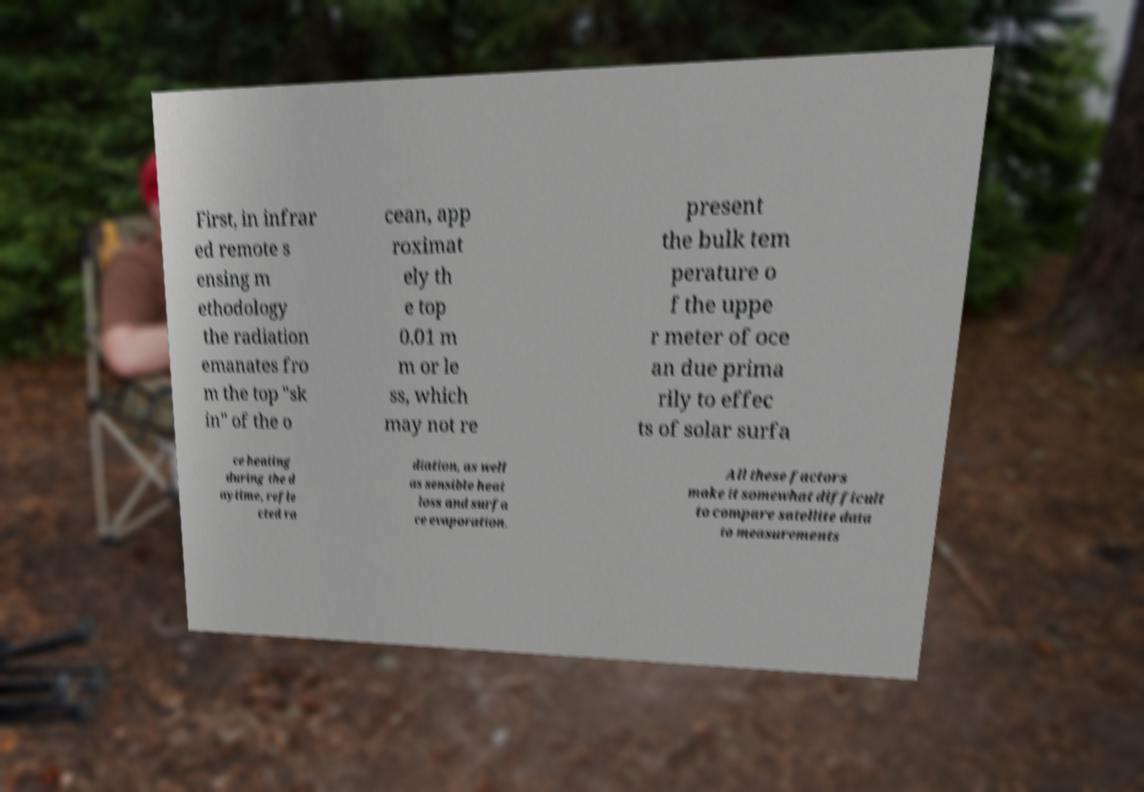Could you extract and type out the text from this image? First, in infrar ed remote s ensing m ethodology the radiation emanates fro m the top "sk in" of the o cean, app roximat ely th e top 0.01 m m or le ss, which may not re present the bulk tem perature o f the uppe r meter of oce an due prima rily to effec ts of solar surfa ce heating during the d aytime, refle cted ra diation, as well as sensible heat loss and surfa ce evaporation. All these factors make it somewhat difficult to compare satellite data to measurements 